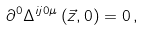Convert formula to latex. <formula><loc_0><loc_0><loc_500><loc_500>\partial ^ { 0 } \Delta ^ { i j 0 \mu } \left ( \vec { z } , 0 \right ) = 0 \, ,</formula> 